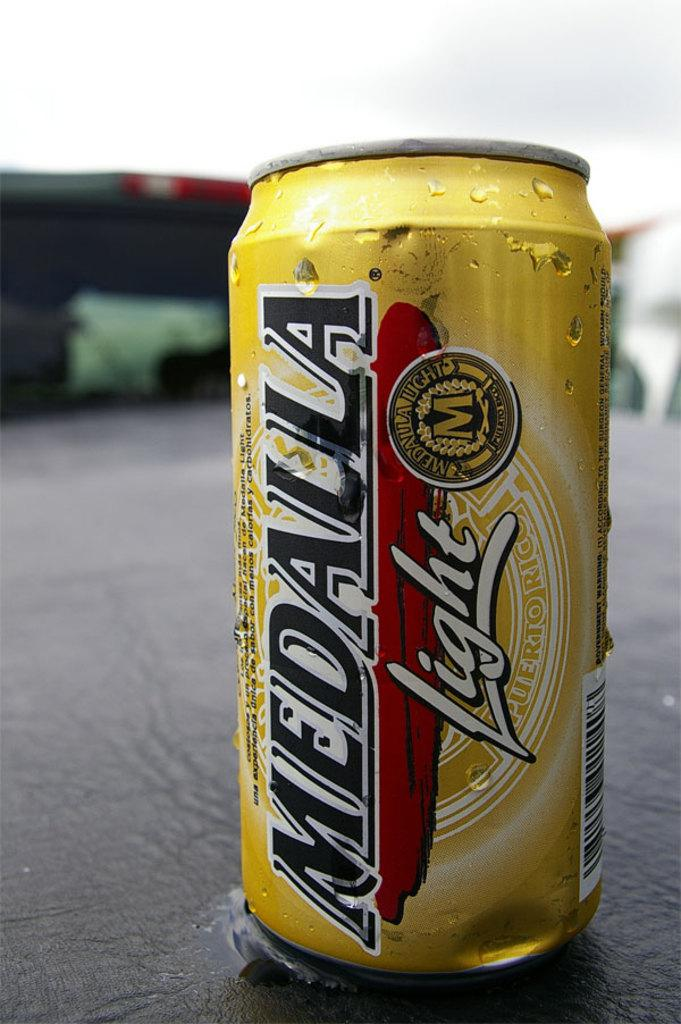<image>
Provide a brief description of the given image. a can of MEDALLA Light beverage stamped Puerto Rico. 